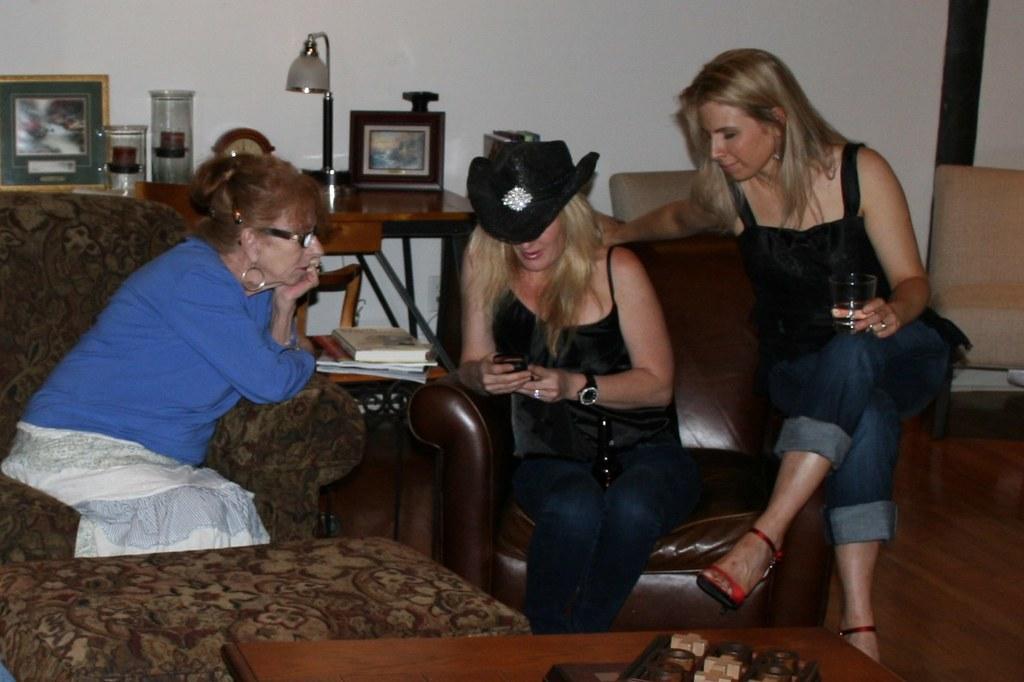Can you describe this image briefly? These three women are sitting on a chair. This woman wore hat and looking at her mobile. This woman is holding a glass and looking at this woman mobile. On this table there are books. Far there is a table,on this table there are pictures, lantern lamp and clock. 